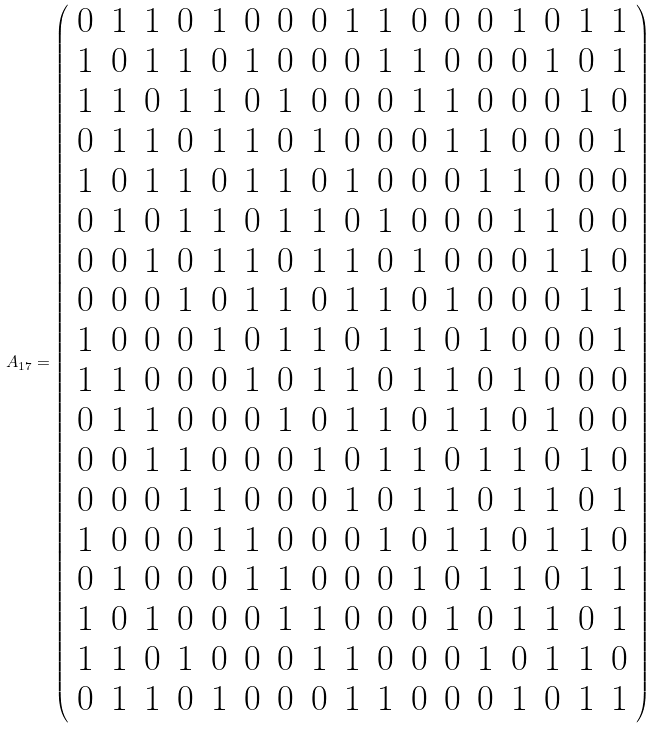<formula> <loc_0><loc_0><loc_500><loc_500>A _ { 1 7 } = \left ( \begin{array} { c c c c c c c c c c c c c c c c c } 0 & 1 & 1 & 0 & 1 & 0 & 0 & 0 & 1 & 1 & 0 & 0 & 0 & 1 & 0 & 1 & 1 \\ 1 & 0 & 1 & 1 & 0 & 1 & 0 & 0 & 0 & 1 & 1 & 0 & 0 & 0 & 1 & 0 & 1 \\ 1 & 1 & 0 & 1 & 1 & 0 & 1 & 0 & 0 & 0 & 1 & 1 & 0 & 0 & 0 & 1 & 0 \\ 0 & 1 & 1 & 0 & 1 & 1 & 0 & 1 & 0 & 0 & 0 & 1 & 1 & 0 & 0 & 0 & 1 \\ 1 & 0 & 1 & 1 & 0 & 1 & 1 & 0 & 1 & 0 & 0 & 0 & 1 & 1 & 0 & 0 & 0 \\ 0 & 1 & 0 & 1 & 1 & 0 & 1 & 1 & 0 & 1 & 0 & 0 & 0 & 1 & 1 & 0 & 0 \\ 0 & 0 & 1 & 0 & 1 & 1 & 0 & 1 & 1 & 0 & 1 & 0 & 0 & 0 & 1 & 1 & 0 \\ 0 & 0 & 0 & 1 & 0 & 1 & 1 & 0 & 1 & 1 & 0 & 1 & 0 & 0 & 0 & 1 & 1 \\ 1 & 0 & 0 & 0 & 1 & 0 & 1 & 1 & 0 & 1 & 1 & 0 & 1 & 0 & 0 & 0 & 1 \\ 1 & 1 & 0 & 0 & 0 & 1 & 0 & 1 & 1 & 0 & 1 & 1 & 0 & 1 & 0 & 0 & 0 \\ 0 & 1 & 1 & 0 & 0 & 0 & 1 & 0 & 1 & 1 & 0 & 1 & 1 & 0 & 1 & 0 & 0 \\ 0 & 0 & 1 & 1 & 0 & 0 & 0 & 1 & 0 & 1 & 1 & 0 & 1 & 1 & 0 & 1 & 0 \\ 0 & 0 & 0 & 1 & 1 & 0 & 0 & 0 & 1 & 0 & 1 & 1 & 0 & 1 & 1 & 0 & 1 \\ 1 & 0 & 0 & 0 & 1 & 1 & 0 & 0 & 0 & 1 & 0 & 1 & 1 & 0 & 1 & 1 & 0 \\ 0 & 1 & 0 & 0 & 0 & 1 & 1 & 0 & 0 & 0 & 1 & 0 & 1 & 1 & 0 & 1 & 1 \\ 1 & 0 & 1 & 0 & 0 & 0 & 1 & 1 & 0 & 0 & 0 & 1 & 0 & 1 & 1 & 0 & 1 \\ 1 & 1 & 0 & 1 & 0 & 0 & 0 & 1 & 1 & 0 & 0 & 0 & 1 & 0 & 1 & 1 & 0 \\ 0 & 1 & 1 & 0 & 1 & 0 & 0 & 0 & 1 & 1 & 0 & 0 & 0 & 1 & 0 & 1 & 1 \\ \end{array} \right )</formula> 